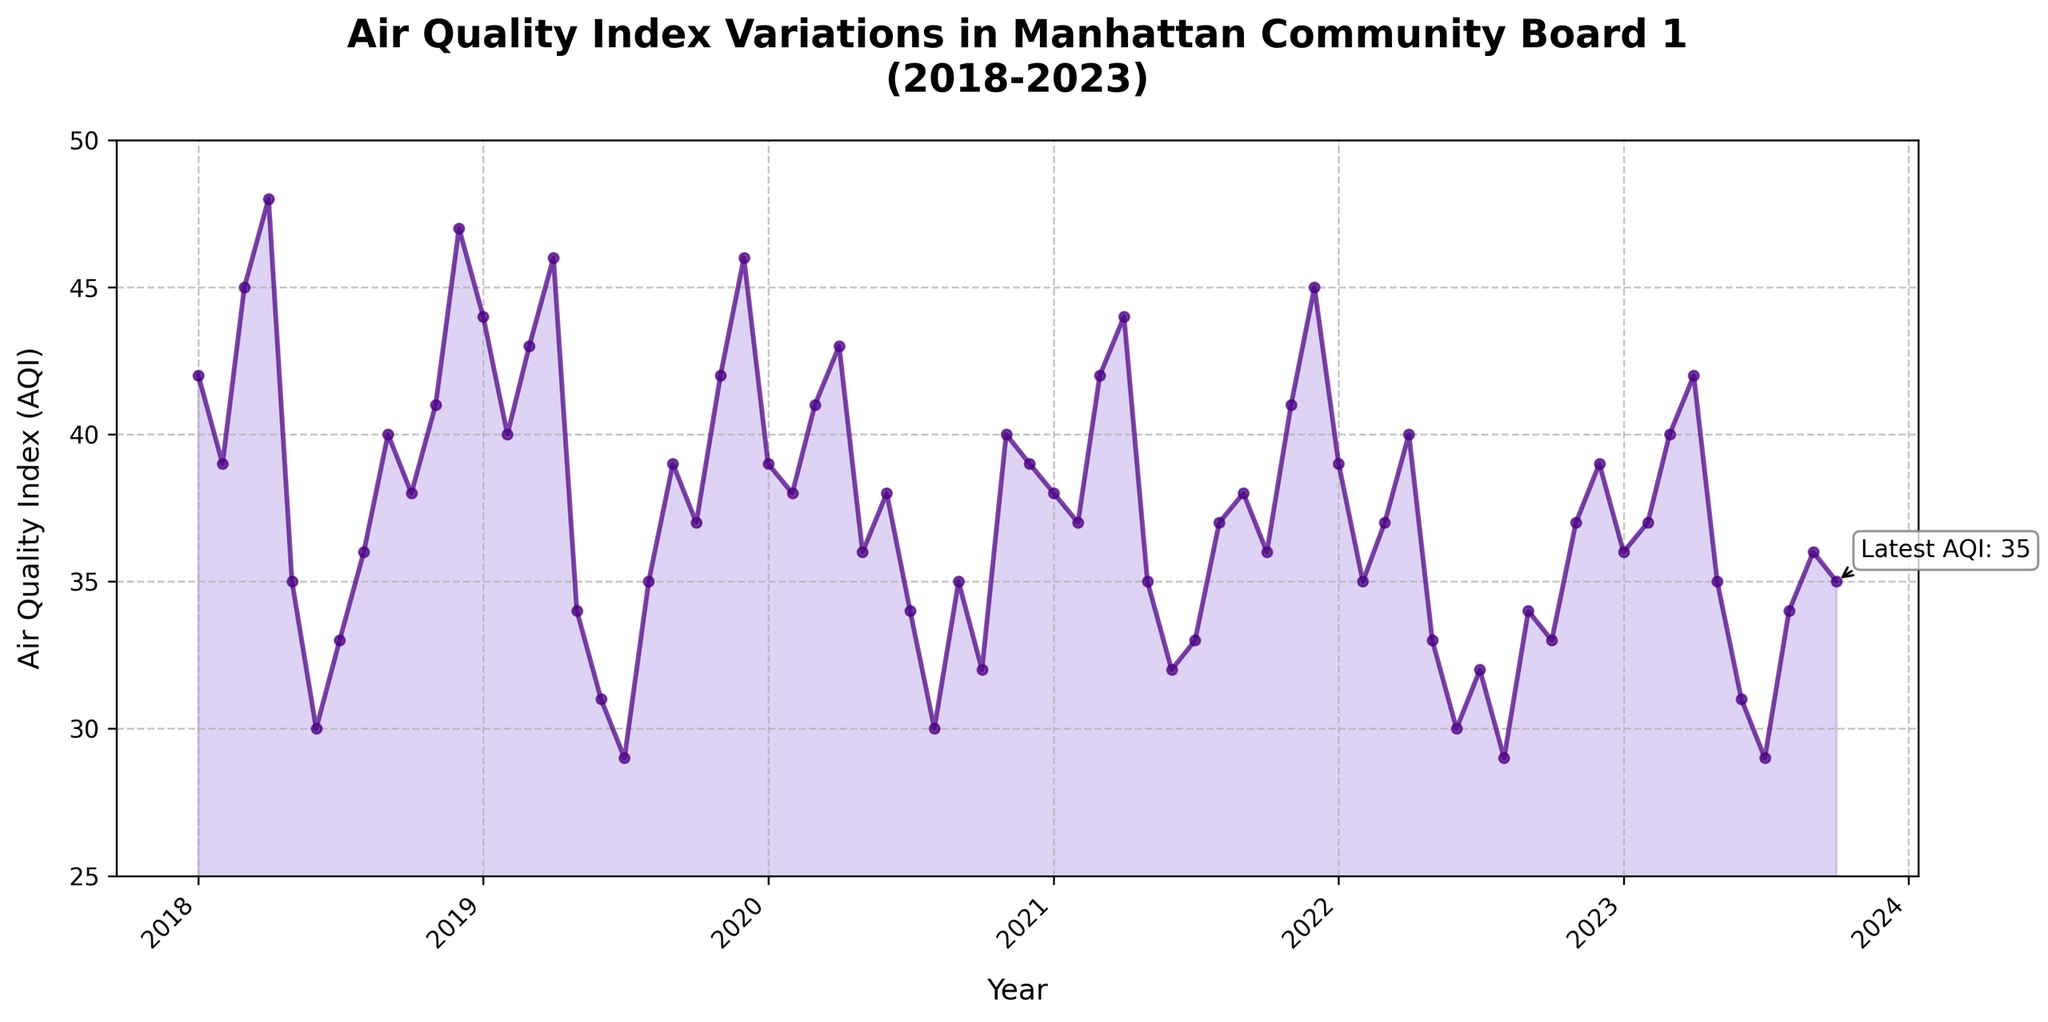What is the title of the plot? The title of the plot is located at the top center, displaying the main subject of the visualization.
Answer: Air Quality Index Variations in Manhattan Community Board 1 (2018-2023) How many data points are plotted in the figure? Each date on the x-axis corresponds to a data point, which ranges from January 2018 to October 2023. Counting these dates provides the number of data points.
Answer: 70 What is the range of the AQI values shown on the y-axis? The y-axis displays the range of AQI values, starting from the minimum to the maximum values labeled on the axis.
Answer: 25 to 50 As of the latest date, what is the AQI value? The latest AQI value is annotated on the plot near the end of the time series. It is also indicated by a text box with an arrow pointing to the specific data point.
Answer: 35 How many times does the AQI value drop below 30? Observing the plot, we see these occurrences whenever the line drops below the 30 mark on the y-axis.
Answer: 2 What is the average AQI value for the year 2019? To find the average AQI for 2019, identify the AQI values for each month in 2019 and compute their average.
Answer: 38.33 In which year did the AQI have the highest monthly value and what was that value? The highest monthly value is identifiable as the peak point on the plot. Checking the corresponding year provides the answer.
Answer: 2018, 48 Compare the AQI values for January 2018 and January 2023. Which one is higher and by how much? By finding the AQI values for January 2018 and January 2023 on the plot and comparing them, we calculate the difference.
Answer: January 2018 by 6 (42 in 2018, 36 in 2023) What is the trend in AQI values from 2018 to 2023? Observing the overall direction of the line from the left side to the right side of the plot indicates whether the AQI values are generally increasing, decreasing, or remaining stable over time.
Answer: Generally stable with slight variations Which months typically have lower AQI values, summer or winter months? By identifying and comparing AQI values during the summer (June to August) and winter (December to February) for each year, we determine which season shows lower values.
Answer: Generally summer months have lower AQI values 